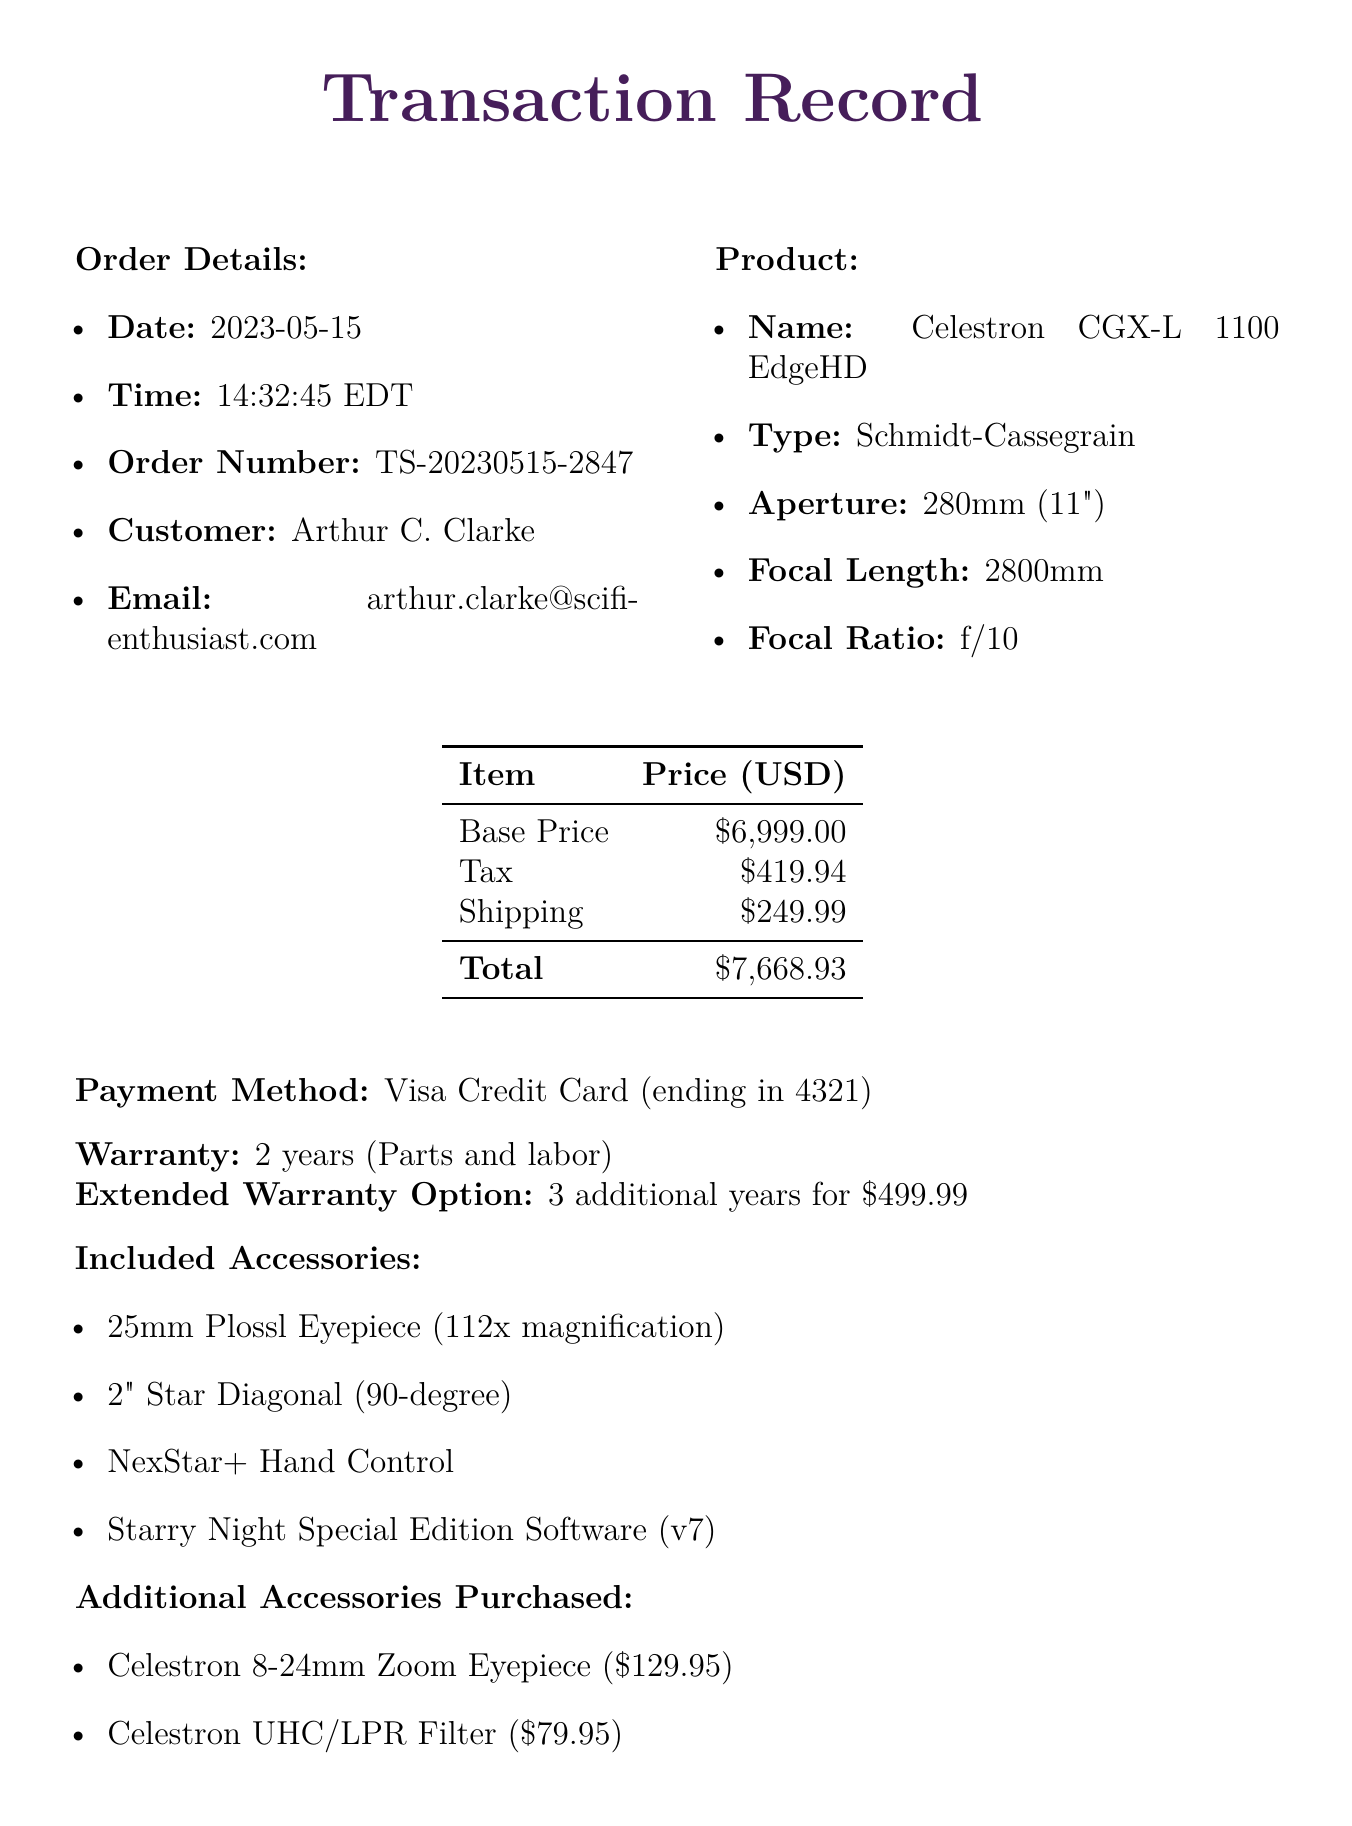What is the order number? The order number can be found in the transaction details section of the document.
Answer: TS-20230515-2847 What is the total price of the purchase? The total price is calculated from the base price, tax, and shipping as mentioned in the pricing section.
Answer: 7668.93 Who is the seller? The seller's name is specified in the seller information section of the document.
Answer: AstroGear Emporium How long is the warranty duration? The warranty duration is stated in the warranty section of the document.
Answer: 2 years What is the shipping method? The shipping method is detailed under the shipping details section in the document.
Answer: FedEx Ground How many additional accessories were purchased? This information can be inferred from the list of additional accessories purchased.
Answer: 3 What is the magnification of the included eyepiece? The magnification is stated next to the 25mm Plossl Eyepiece in the accessories included section.
Answer: 112x What is the purpose of the Celestron UHC/LPR Filter? The purpose of the filter is given in the additional accessories purchased section.
Answer: Light pollution reduction What is the estimated delivery date? The estimated delivery date is outlined in the shipping details section of the document.
Answer: 2023-05-22 